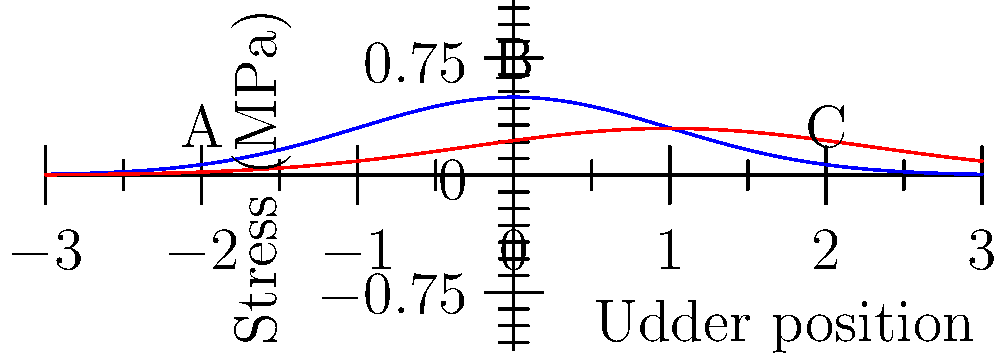Based on the stress distribution graph of a cow's udder during milk production, which point experiences the highest stress during the milking phase, and how does this compare to the resting phase? To answer this question, we need to analyze the graph and understand the stress distribution in the cow's udder:

1. The blue curve represents the stress distribution during the milking phase.
2. The red curve represents the stress distribution during the resting phase.
3. Three points are labeled on the graph: A, B, and C.

Step 1: Identify the highest point on the blue curve (milking phase).
- Point B is clearly at the peak of the blue curve.

Step 2: Compare the stress levels at points A, B, and C during the milking phase.
- Point A: approximately 0.2 MPa
- Point B: approximately 0.5 MPa
- Point C: approximately 0.2 MPa

Step 3: Compare the stress at point B during milking and resting phases.
- Milking phase (blue curve): approximately 0.5 MPa
- Resting phase (red curve): approximately 0.2 MPa

Step 4: Interpret the results.
- Point B experiences the highest stress during the milking phase.
- The stress at point B is significantly higher during the milking phase compared to the resting phase.

This stress distribution is crucial for dairy producers to understand, as it impacts udder health, milk production efficiency, and overall animal welfare.
Answer: Point B; stress is highest during milking and significantly lower during rest. 